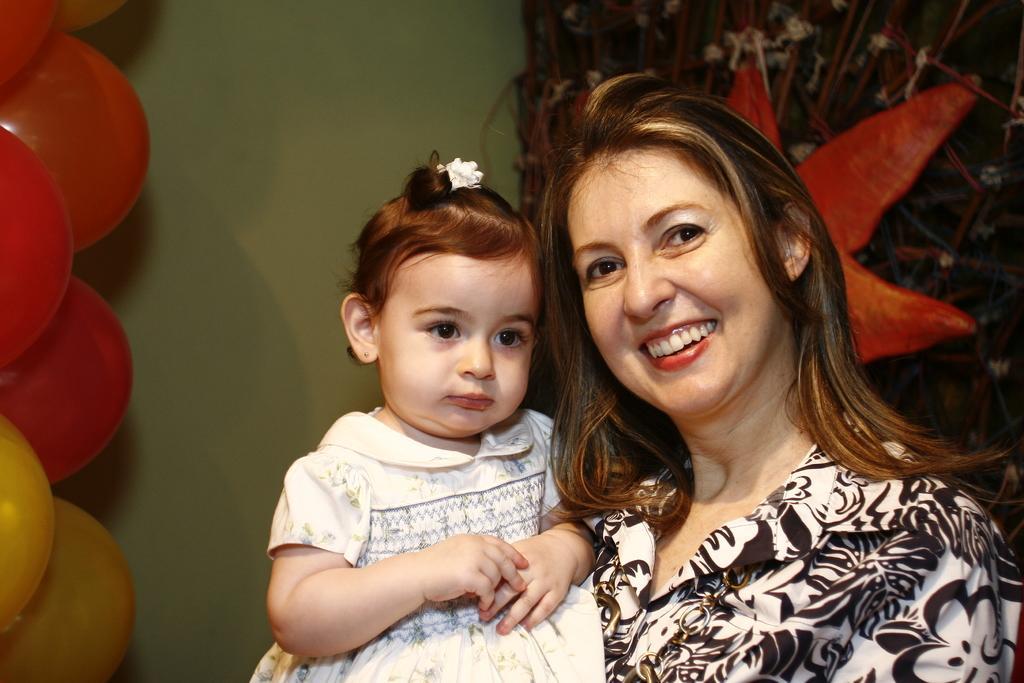Describe this image in one or two sentences. In this image I see a woman who is wearing white and black dress and I see that she is smiling and I can also see that she is holding a baby in her hands. In the background I see the wall and I see number of balloons over here which are of orange, red and yellow in color and I see the red color thing over here. 